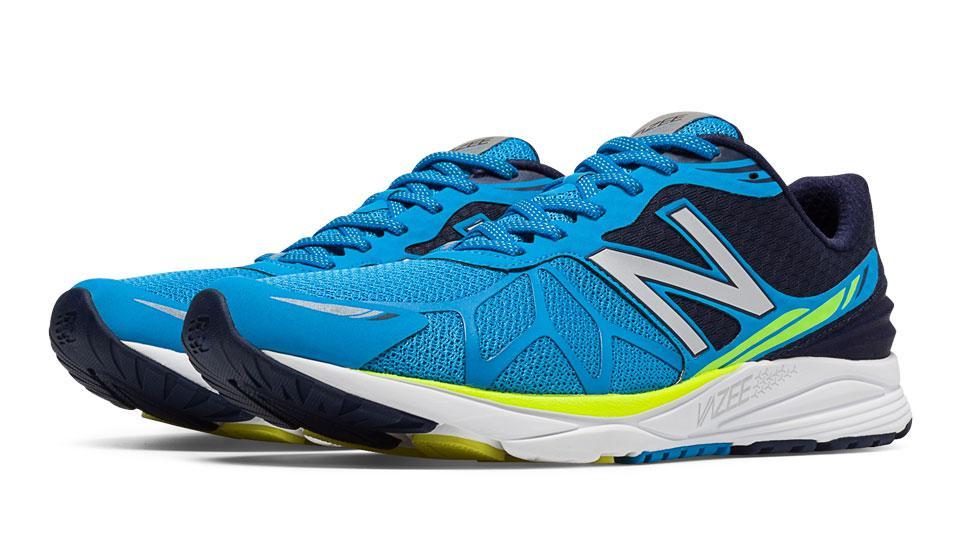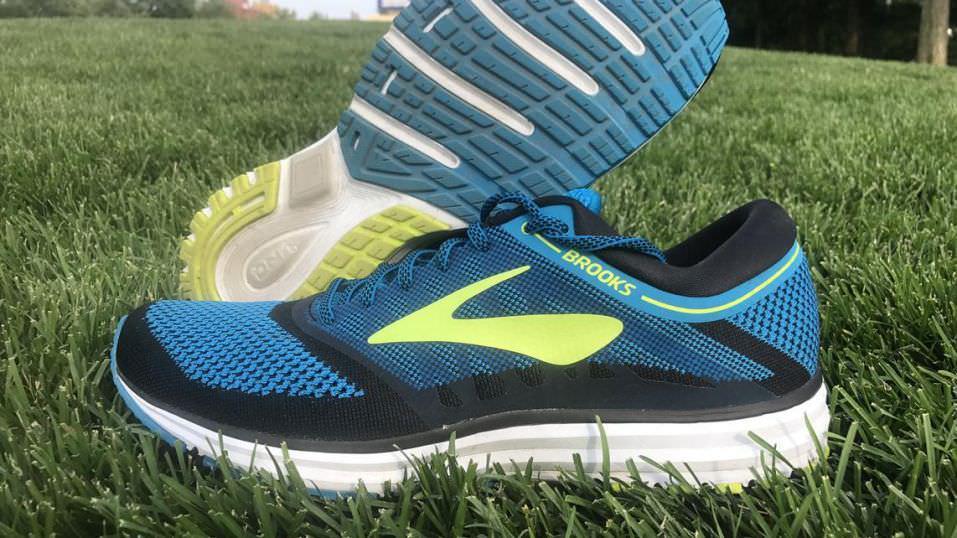The first image is the image on the left, the second image is the image on the right. For the images shown, is this caption "There are 2 shoes facing to the right." true? Answer yes or no. No. 